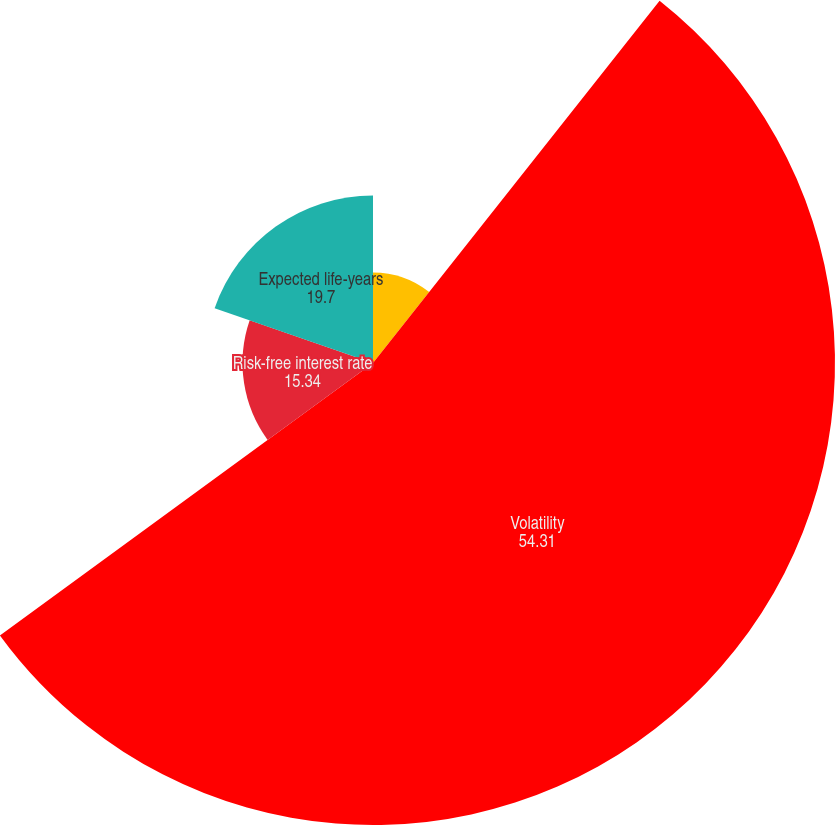Convert chart to OTSL. <chart><loc_0><loc_0><loc_500><loc_500><pie_chart><fcel>Dividend yield<fcel>Volatility<fcel>Risk-free interest rate<fcel>Expected life-years<nl><fcel>10.65%<fcel>54.31%<fcel>15.34%<fcel>19.7%<nl></chart> 